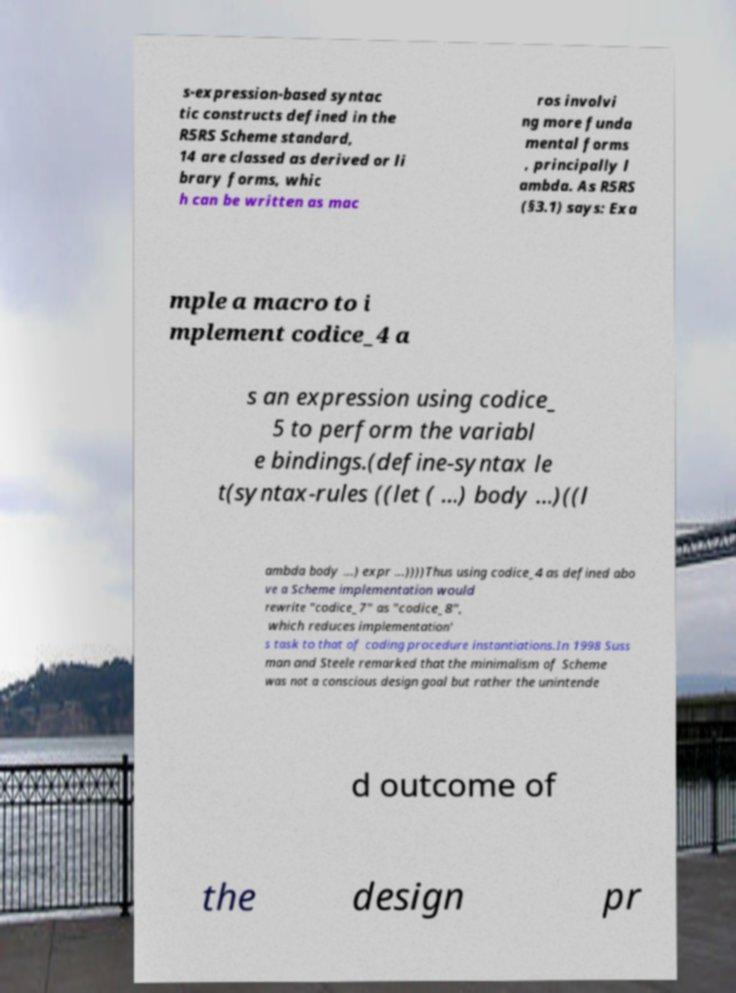Can you accurately transcribe the text from the provided image for me? s-expression-based syntac tic constructs defined in the R5RS Scheme standard, 14 are classed as derived or li brary forms, whic h can be written as mac ros involvi ng more funda mental forms , principally l ambda. As R5RS (§3.1) says: Exa mple a macro to i mplement codice_4 a s an expression using codice_ 5 to perform the variabl e bindings.(define-syntax le t(syntax-rules ((let ( ...) body ...)((l ambda body ...) expr ...))))Thus using codice_4 as defined abo ve a Scheme implementation would rewrite "codice_7" as "codice_8", which reduces implementation' s task to that of coding procedure instantiations.In 1998 Suss man and Steele remarked that the minimalism of Scheme was not a conscious design goal but rather the unintende d outcome of the design pr 